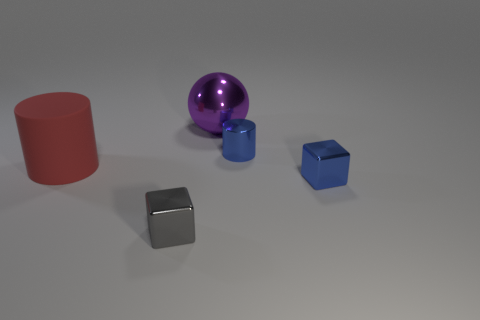Add 5 large spheres. How many objects exist? 10 Subtract all cubes. How many objects are left? 3 Subtract 0 gray balls. How many objects are left? 5 Subtract all large purple metallic spheres. Subtract all small gray blocks. How many objects are left? 3 Add 5 cylinders. How many cylinders are left? 7 Add 1 blue metal objects. How many blue metal objects exist? 3 